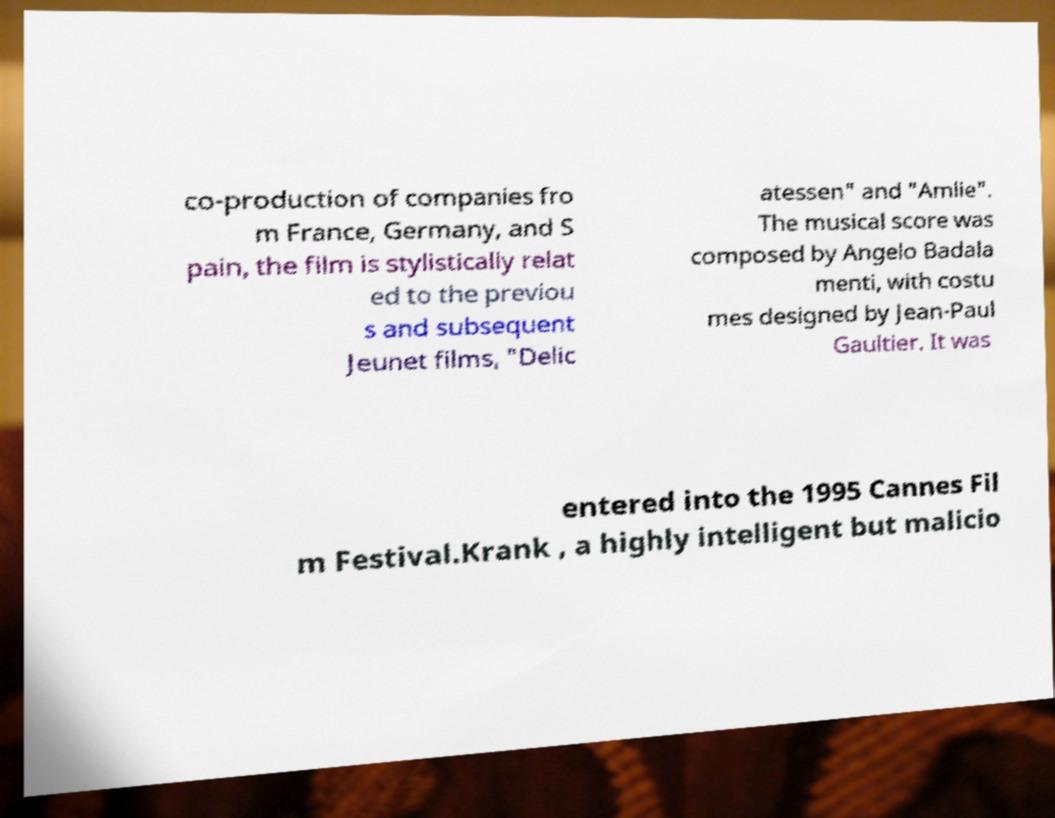For documentation purposes, I need the text within this image transcribed. Could you provide that? co-production of companies fro m France, Germany, and S pain, the film is stylistically relat ed to the previou s and subsequent Jeunet films, "Delic atessen" and "Amlie". The musical score was composed by Angelo Badala menti, with costu mes designed by Jean-Paul Gaultier. It was entered into the 1995 Cannes Fil m Festival.Krank , a highly intelligent but malicio 